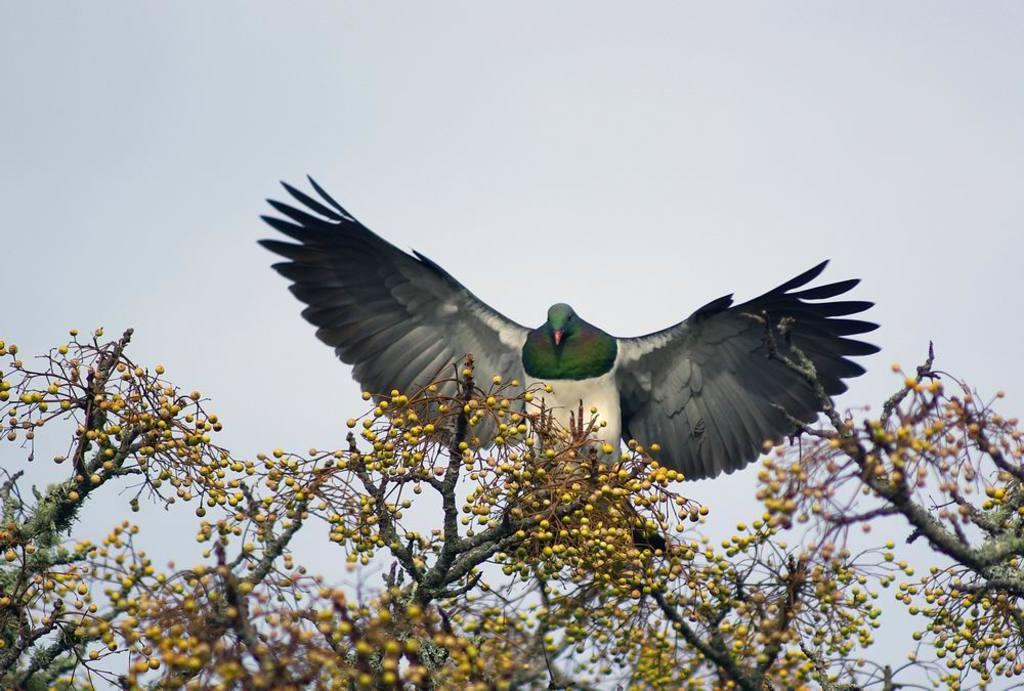What type of vegetation is visible at the bottom of the image? There are branches of trees with seeds at the bottom of the image. What animal can be seen in the image? There is a bird flying in the image. What part of the natural environment is visible in the background of the image? The sky is visible in the background of the image. What is the name of the bird flying in the image? The provided facts do not include the name of the bird, so it cannot be determined from the image. Can you describe the coil-like structure present in the image? There is no coil-like structure present in the image; it features branches of trees, seeds, and a flying bird. 